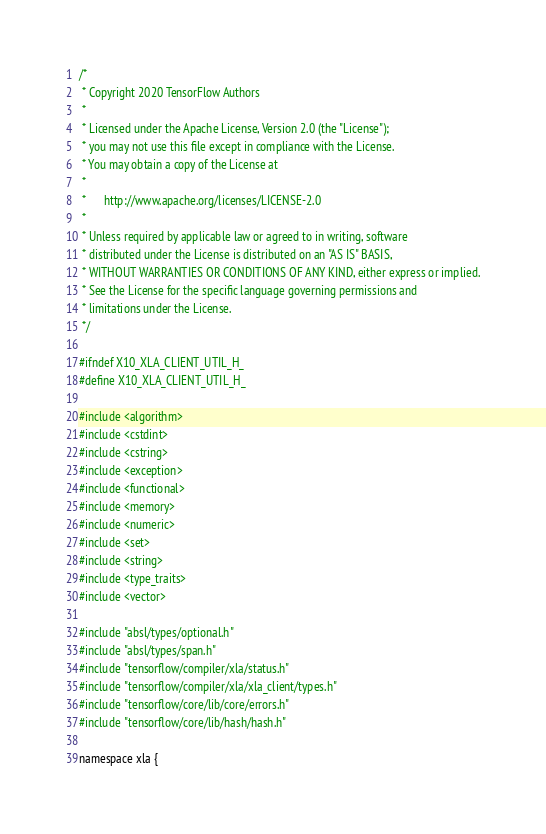Convert code to text. <code><loc_0><loc_0><loc_500><loc_500><_C_>/*
 * Copyright 2020 TensorFlow Authors
 *
 * Licensed under the Apache License, Version 2.0 (the "License");
 * you may not use this file except in compliance with the License.
 * You may obtain a copy of the License at
 *
 *      http://www.apache.org/licenses/LICENSE-2.0
 *
 * Unless required by applicable law or agreed to in writing, software
 * distributed under the License is distributed on an "AS IS" BASIS,
 * WITHOUT WARRANTIES OR CONDITIONS OF ANY KIND, either express or implied.
 * See the License for the specific language governing permissions and
 * limitations under the License.
 */

#ifndef X10_XLA_CLIENT_UTIL_H_
#define X10_XLA_CLIENT_UTIL_H_

#include <algorithm>
#include <cstdint>
#include <cstring>
#include <exception>
#include <functional>
#include <memory>
#include <numeric>
#include <set>
#include <string>
#include <type_traits>
#include <vector>

#include "absl/types/optional.h"
#include "absl/types/span.h"
#include "tensorflow/compiler/xla/status.h"
#include "tensorflow/compiler/xla/xla_client/types.h"
#include "tensorflow/core/lib/core/errors.h"
#include "tensorflow/core/lib/hash/hash.h"

namespace xla {</code> 